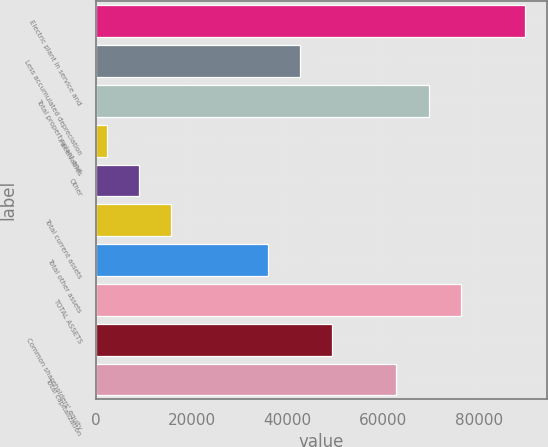Convert chart to OTSL. <chart><loc_0><loc_0><loc_500><loc_500><bar_chart><fcel>Electric plant in service and<fcel>Less accumulated depreciation<fcel>Total property plant and<fcel>Receivables<fcel>Other<fcel>Total current assets<fcel>Total other assets<fcel>TOTAL ASSETS<fcel>Common shareholders' equity<fcel>Total capitalization<nl><fcel>89595.7<fcel>42584.4<fcel>69448<fcel>2289<fcel>9004.9<fcel>15720.8<fcel>35868.5<fcel>76163.9<fcel>49300.3<fcel>62732.1<nl></chart> 